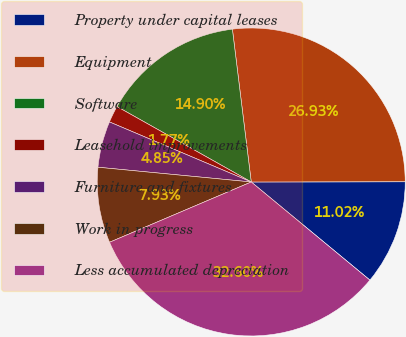Convert chart to OTSL. <chart><loc_0><loc_0><loc_500><loc_500><pie_chart><fcel>Property under capital leases<fcel>Equipment<fcel>Software<fcel>Leasehold improvements<fcel>Furniture and fixtures<fcel>Work in progress<fcel>Less accumulated depreciation<nl><fcel>11.02%<fcel>26.93%<fcel>14.9%<fcel>1.77%<fcel>4.85%<fcel>7.93%<fcel>32.6%<nl></chart> 